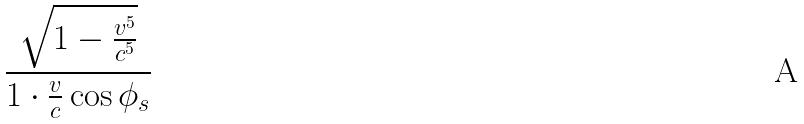<formula> <loc_0><loc_0><loc_500><loc_500>\frac { \sqrt { 1 - \frac { v ^ { 5 } } { c ^ { 5 } } } } { 1 \cdot \frac { v } { c } \cos \phi _ { s } }</formula> 